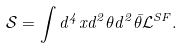Convert formula to latex. <formula><loc_0><loc_0><loc_500><loc_500>\mathcal { S } = \int d ^ { 4 } x d ^ { 2 } \theta d ^ { 2 } { \bar { \theta } } \mathcal { L } ^ { S F } .</formula> 